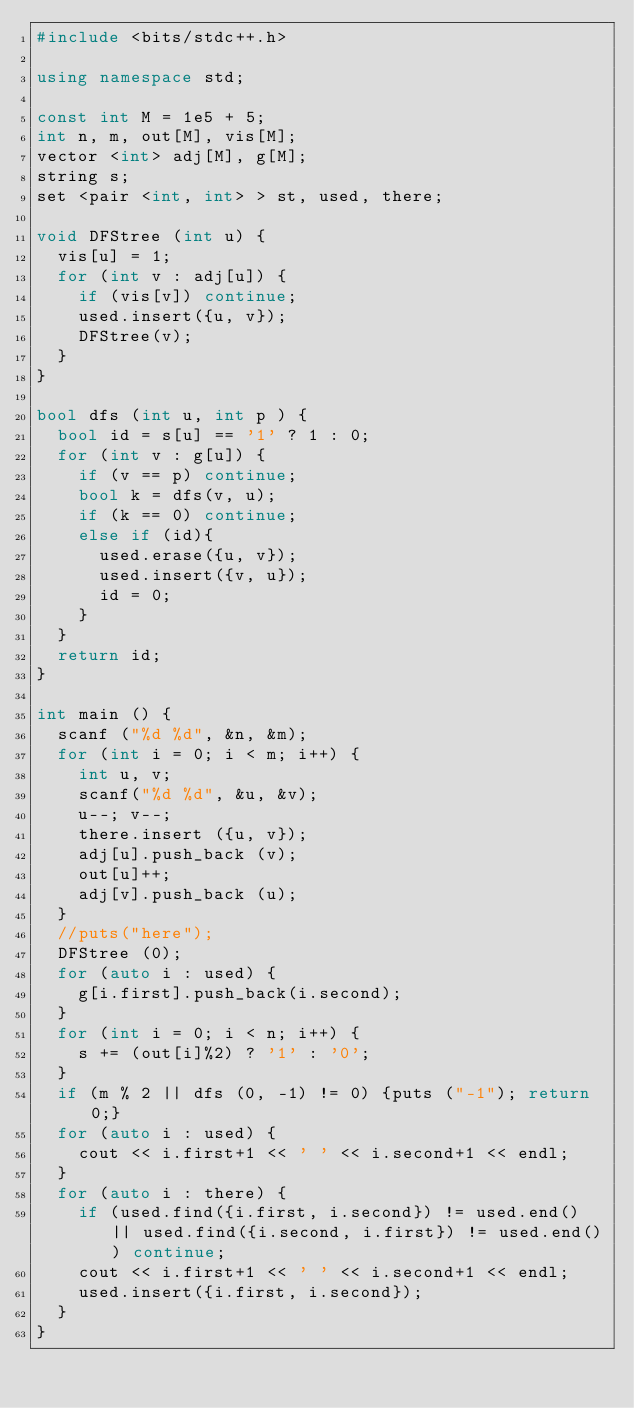Convert code to text. <code><loc_0><loc_0><loc_500><loc_500><_C++_>#include <bits/stdc++.h>

using namespace std;

const int M = 1e5 + 5;
int n, m, out[M], vis[M];
vector <int> adj[M], g[M];
string s;
set <pair <int, int> > st, used, there;

void DFStree (int u) {
  vis[u] = 1;
  for (int v : adj[u]) {
    if (vis[v]) continue;
    used.insert({u, v});
    DFStree(v);
  } 
}

bool dfs (int u, int p ) {
  bool id = s[u] == '1' ? 1 : 0;
  for (int v : g[u]) {
    if (v == p) continue;
    bool k = dfs(v, u);
    if (k == 0) continue;
    else if (id){
      used.erase({u, v});
      used.insert({v, u});
      id = 0;
    }
  }
  return id;
}

int main () {
  scanf ("%d %d", &n, &m);
  for (int i = 0; i < m; i++) {
    int u, v;
    scanf("%d %d", &u, &v);
    u--; v--; 
    there.insert ({u, v});
    adj[u].push_back (v);
    out[u]++;
    adj[v].push_back (u);
  }
  //puts("here");
  DFStree (0);
  for (auto i : used) {
    g[i.first].push_back(i.second);
  }
  for (int i = 0; i < n; i++) {
    s += (out[i]%2) ? '1' : '0';
  }
  if (m % 2 || dfs (0, -1) != 0) {puts ("-1"); return 0;}
  for (auto i : used) {
    cout << i.first+1 << ' ' << i.second+1 << endl;
  }
  for (auto i : there) {
    if (used.find({i.first, i.second}) != used.end() || used.find({i.second, i.first}) != used.end()) continue;
    cout << i.first+1 << ' ' << i.second+1 << endl;
    used.insert({i.first, i.second});
  }
}</code> 